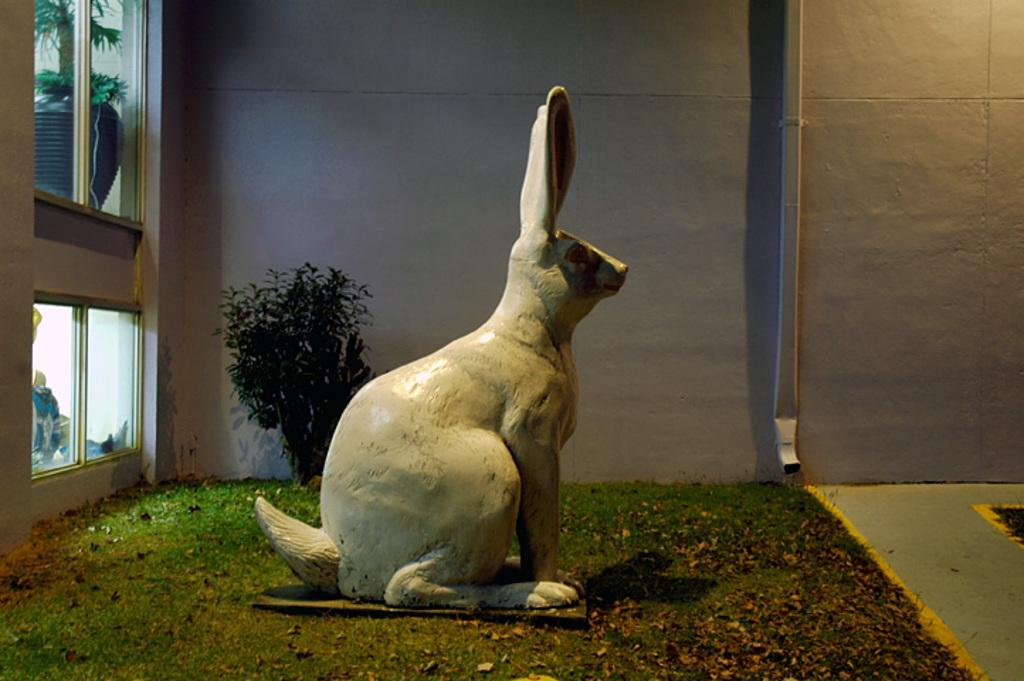What type of sculpture is present in the image? There is a rabbit sculpture in the image. What type of vegetation can be seen in the image? There is grass and plants in the image. What objects are present in the image that might be used for holding plants? There are pots in the image. What type of structure can be seen in the background of the image? There is a wall in the image. How many bikes are parked next to the wall in the image? There are no bikes present in the image. What type of engine can be seen powering the rabbit sculpture in the image? There is no engine present in the image, and the rabbit sculpture is not powered. 